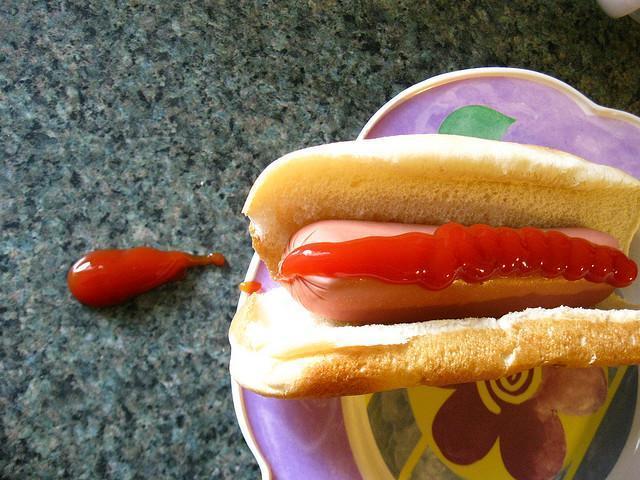How many people are holding surf boards?
Give a very brief answer. 0. 